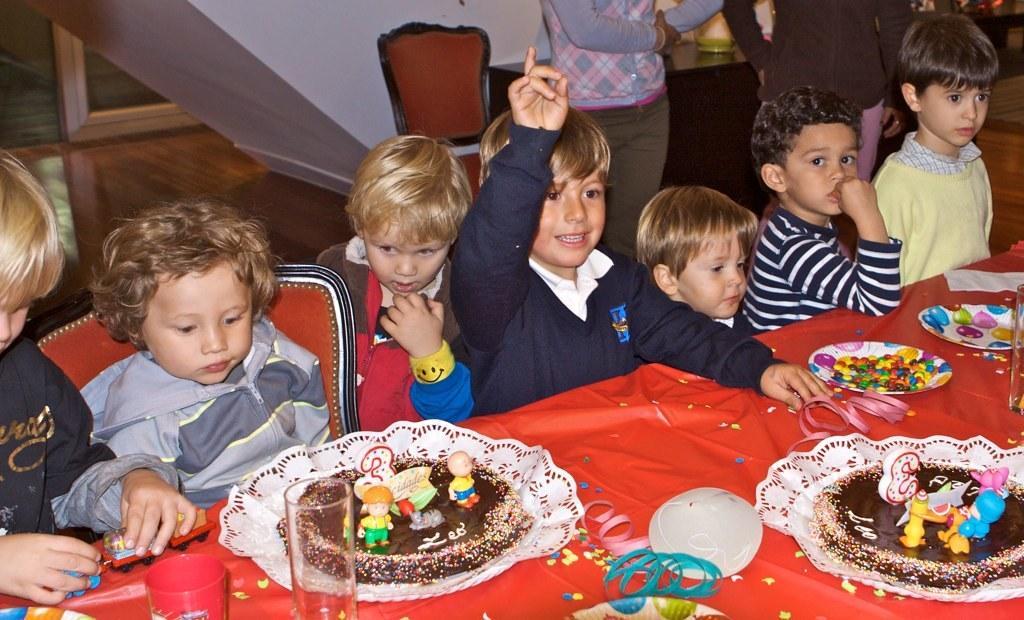Please provide a concise description of this image. In this image few kids are behind the table. On the table there are few plates and glasses. Left bottom there is a plate having a cake which is having few toys on it. Beside the plate there are two glasses. Left side there is a kid holding an object in his hand. Beside him there is a kid sitting on the chair. Right bottom there is a plate having a cake with few toys on it. Beside there is a plate having few gems in it. Right side there is a glass, behind there is a plate which is on the table. Top of the image few persons are standing. Behind them there is a table having few objects on it. Beside the table there is a chair. Background there is a wall. 